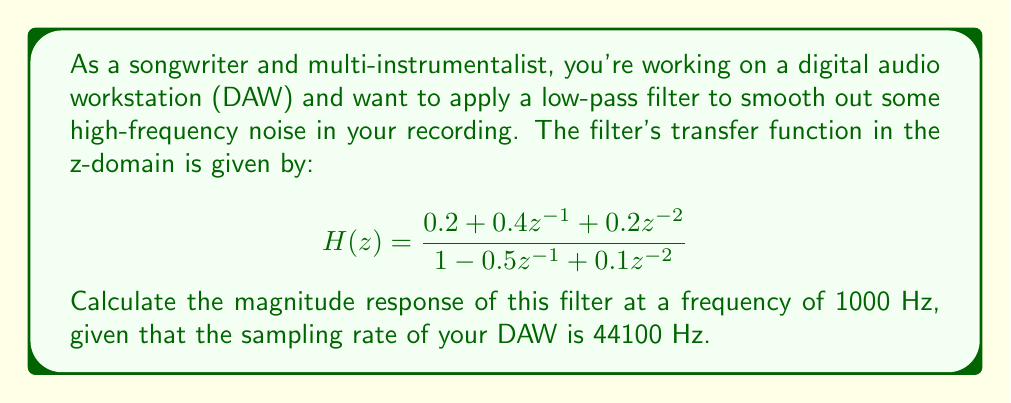Provide a solution to this math problem. To solve this problem, we'll follow these steps:

1) First, we need to convert the frequency from Hz to normalized frequency $\omega$ (radians per sample):

   $$\omega = 2\pi \frac{f}{f_s} = 2\pi \frac{1000}{44100} \approx 0.1425$$ rad/sample

2) Next, we substitute $z = e^{j\omega}$ into the transfer function:

   $$H(e^{j\omega}) = \frac{0.2 + 0.4e^{-j\omega} + 0.2e^{-j2\omega}}{1 - 0.5e^{-j\omega} + 0.1e^{-j2\omega}}$$

3) We can separate the numerator and denominator into real and imaginary parts:

   Numerator: $0.2 + 0.4(\cos\omega - j\sin\omega) + 0.2(\cos2\omega - j\sin2\omega)$
   
   Denominator: $1 - 0.5(\cos\omega - j\sin\omega) + 0.1(\cos2\omega - j\sin2\omega)$

4) Substituting $\omega = 0.1425$:

   Numerator: $0.2 + 0.4(0.9899 - j0.1417) + 0.2(0.9600 - j0.2801)$
            $= 0.7880 - j0.1227$

   Denominator: $1 - 0.5(0.9899 - j0.1417) + 0.1(0.9600 - j0.2801)$
               $= 0.5910 + j0.0429$

5) The magnitude response is the absolute value of the complex fraction:

   $$|H(e^{j\omega})| = \left|\frac{0.7880 - j0.1227}{0.5910 + j0.0429}\right|$$

6) We can calculate this using the formula $|a+bj| = \sqrt{a^2 + b^2}$:

   $$|H(e^{j\omega})| = \frac{\sqrt{0.7880^2 + (-0.1227)^2}}{\sqrt{0.5910^2 + 0.0429^2}} \approx 1.3372$$

7) Often, the magnitude response is expressed in decibels:

   $$|H(e^{j\omega})|_{dB} = 20 \log_{10}(1.3372) \approx 2.5242$$ dB
Answer: The magnitude response of the filter at 1000 Hz is approximately 1.3372, or 2.5242 dB. 